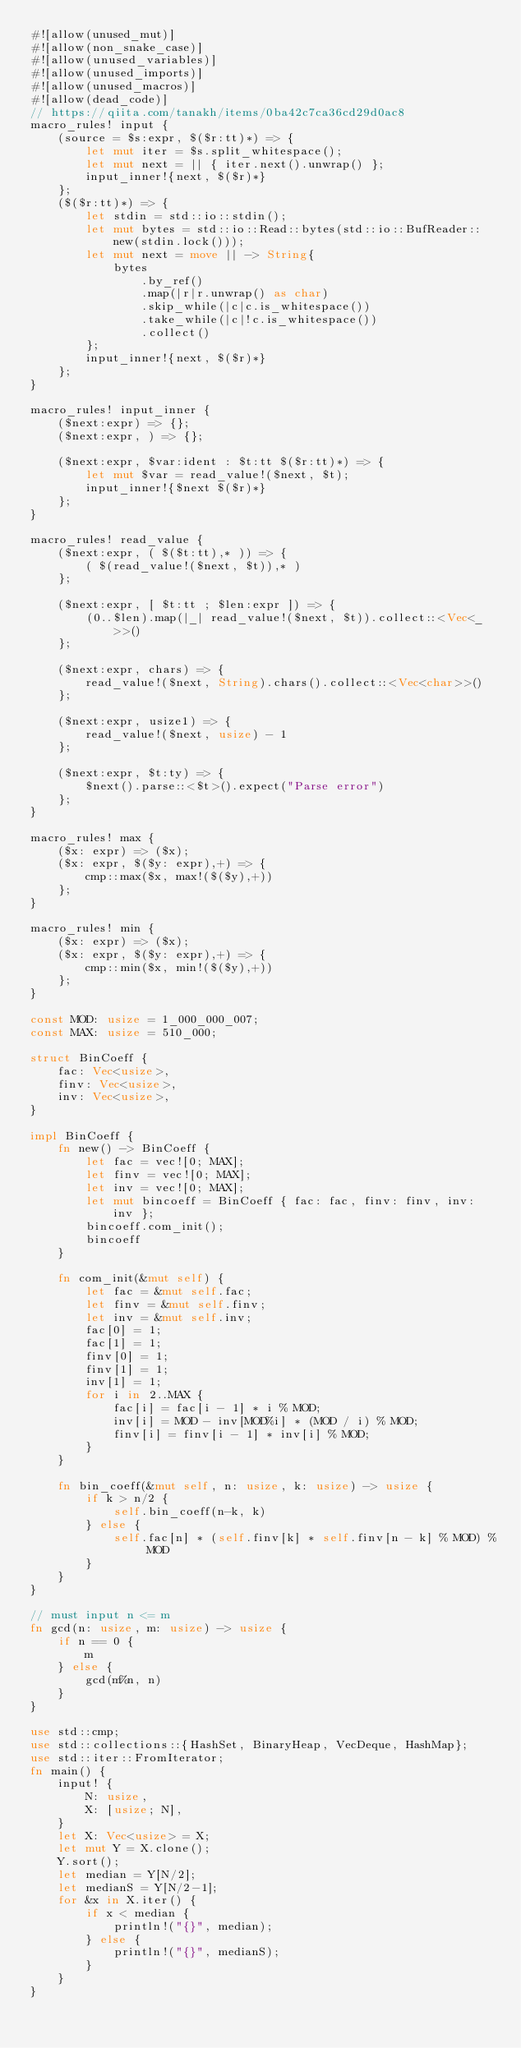<code> <loc_0><loc_0><loc_500><loc_500><_Rust_>#![allow(unused_mut)]
#![allow(non_snake_case)]
#![allow(unused_variables)]
#![allow(unused_imports)]
#![allow(unused_macros)]
#![allow(dead_code)]
// https://qiita.com/tanakh/items/0ba42c7ca36cd29d0ac8
macro_rules! input {
    (source = $s:expr, $($r:tt)*) => {
        let mut iter = $s.split_whitespace();
        let mut next = || { iter.next().unwrap() };
        input_inner!{next, $($r)*}
    };
    ($($r:tt)*) => {
        let stdin = std::io::stdin();
        let mut bytes = std::io::Read::bytes(std::io::BufReader::new(stdin.lock()));
        let mut next = move || -> String{
            bytes
                .by_ref()
                .map(|r|r.unwrap() as char)
                .skip_while(|c|c.is_whitespace())
                .take_while(|c|!c.is_whitespace())
                .collect()
        };
        input_inner!{next, $($r)*}
    };
}

macro_rules! input_inner {
    ($next:expr) => {};
    ($next:expr, ) => {};

    ($next:expr, $var:ident : $t:tt $($r:tt)*) => {
        let mut $var = read_value!($next, $t);
        input_inner!{$next $($r)*}
    };
}

macro_rules! read_value {
    ($next:expr, ( $($t:tt),* )) => {
        ( $(read_value!($next, $t)),* )
    };

    ($next:expr, [ $t:tt ; $len:expr ]) => {
        (0..$len).map(|_| read_value!($next, $t)).collect::<Vec<_>>()
    };

    ($next:expr, chars) => {
        read_value!($next, String).chars().collect::<Vec<char>>()
    };

    ($next:expr, usize1) => {
        read_value!($next, usize) - 1
    };

    ($next:expr, $t:ty) => {
        $next().parse::<$t>().expect("Parse error")
    };
}

macro_rules! max {
    ($x: expr) => ($x);
    ($x: expr, $($y: expr),+) => {
        cmp::max($x, max!($($y),+))
    };
}

macro_rules! min {
    ($x: expr) => ($x);
    ($x: expr, $($y: expr),+) => {
        cmp::min($x, min!($($y),+))
    };
}

const MOD: usize = 1_000_000_007;
const MAX: usize = 510_000;

struct BinCoeff {
    fac: Vec<usize>,
    finv: Vec<usize>,
    inv: Vec<usize>,
}

impl BinCoeff {
    fn new() -> BinCoeff {
        let fac = vec![0; MAX];
        let finv = vec![0; MAX];
        let inv = vec![0; MAX];
        let mut bincoeff = BinCoeff { fac: fac, finv: finv, inv: inv };
        bincoeff.com_init();
        bincoeff
    }

    fn com_init(&mut self) {
        let fac = &mut self.fac;
        let finv = &mut self.finv;
        let inv = &mut self.inv;
        fac[0] = 1;
        fac[1] = 1;
        finv[0] = 1;
        finv[1] = 1;
        inv[1] = 1;
        for i in 2..MAX {
            fac[i] = fac[i - 1] * i % MOD;
            inv[i] = MOD - inv[MOD%i] * (MOD / i) % MOD;
            finv[i] = finv[i - 1] * inv[i] % MOD;
        }
    }

    fn bin_coeff(&mut self, n: usize, k: usize) -> usize {
        if k > n/2 {
            self.bin_coeff(n-k, k)
        } else {
            self.fac[n] * (self.finv[k] * self.finv[n - k] % MOD) % MOD
        }
    }
}

// must input n <= m
fn gcd(n: usize, m: usize) -> usize {
    if n == 0 {
        m
    } else {
        gcd(m%n, n)
    }
}

use std::cmp;
use std::collections::{HashSet, BinaryHeap, VecDeque, HashMap};
use std::iter::FromIterator;
fn main() {
    input! {
        N: usize,
        X: [usize; N],
    }
    let X: Vec<usize> = X;
    let mut Y = X.clone();
    Y.sort();
    let median = Y[N/2];
    let medianS = Y[N/2-1];
    for &x in X.iter() {
        if x < median {
            println!("{}", median);
        } else {
            println!("{}", medianS);
        }
    }
}</code> 